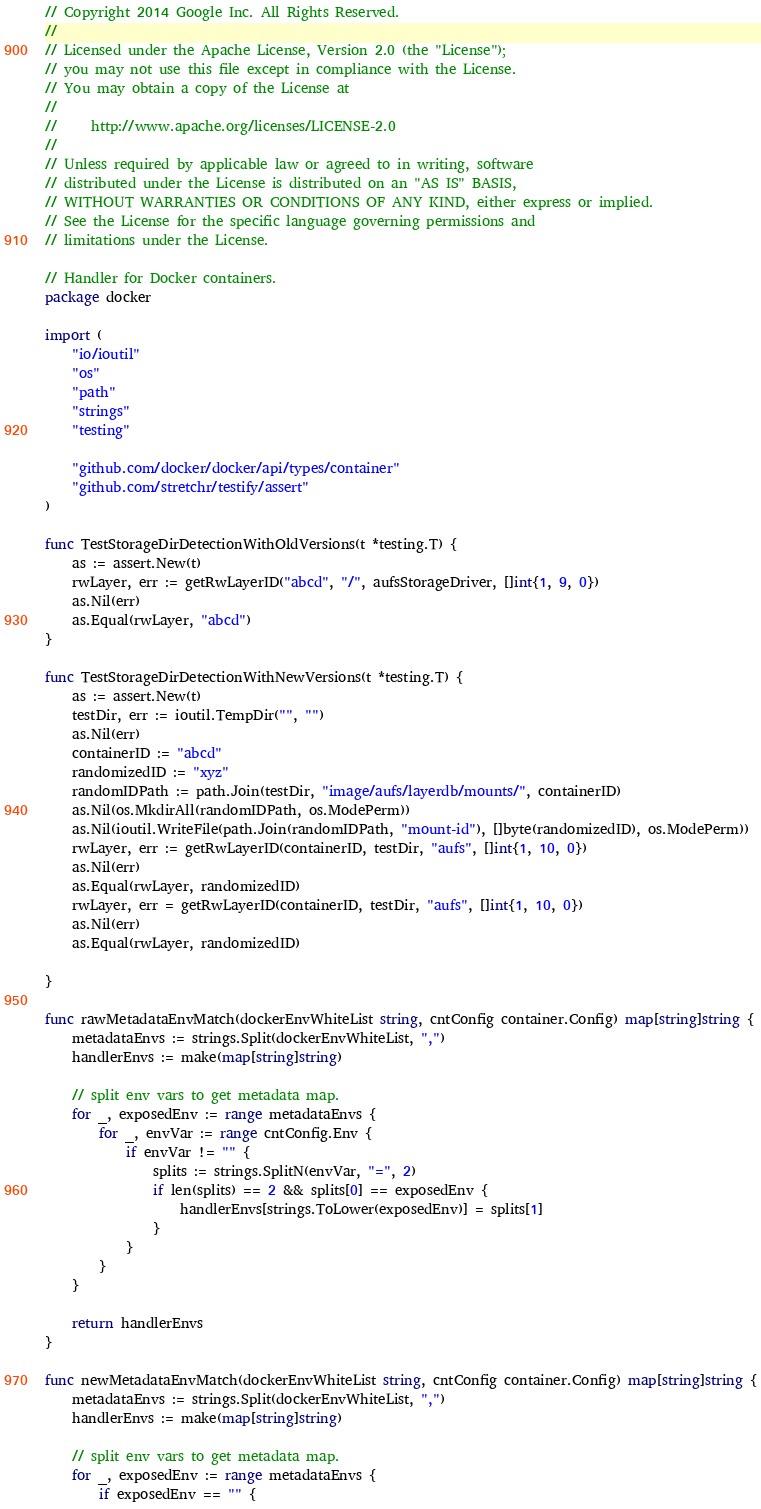<code> <loc_0><loc_0><loc_500><loc_500><_Go_>// Copyright 2014 Google Inc. All Rights Reserved.
//
// Licensed under the Apache License, Version 2.0 (the "License");
// you may not use this file except in compliance with the License.
// You may obtain a copy of the License at
//
//     http://www.apache.org/licenses/LICENSE-2.0
//
// Unless required by applicable law or agreed to in writing, software
// distributed under the License is distributed on an "AS IS" BASIS,
// WITHOUT WARRANTIES OR CONDITIONS OF ANY KIND, either express or implied.
// See the License for the specific language governing permissions and
// limitations under the License.

// Handler for Docker containers.
package docker

import (
	"io/ioutil"
	"os"
	"path"
	"strings"
	"testing"

	"github.com/docker/docker/api/types/container"
	"github.com/stretchr/testify/assert"
)

func TestStorageDirDetectionWithOldVersions(t *testing.T) {
	as := assert.New(t)
	rwLayer, err := getRwLayerID("abcd", "/", aufsStorageDriver, []int{1, 9, 0})
	as.Nil(err)
	as.Equal(rwLayer, "abcd")
}

func TestStorageDirDetectionWithNewVersions(t *testing.T) {
	as := assert.New(t)
	testDir, err := ioutil.TempDir("", "")
	as.Nil(err)
	containerID := "abcd"
	randomizedID := "xyz"
	randomIDPath := path.Join(testDir, "image/aufs/layerdb/mounts/", containerID)
	as.Nil(os.MkdirAll(randomIDPath, os.ModePerm))
	as.Nil(ioutil.WriteFile(path.Join(randomIDPath, "mount-id"), []byte(randomizedID), os.ModePerm))
	rwLayer, err := getRwLayerID(containerID, testDir, "aufs", []int{1, 10, 0})
	as.Nil(err)
	as.Equal(rwLayer, randomizedID)
	rwLayer, err = getRwLayerID(containerID, testDir, "aufs", []int{1, 10, 0})
	as.Nil(err)
	as.Equal(rwLayer, randomizedID)

}

func rawMetadataEnvMatch(dockerEnvWhiteList string, cntConfig container.Config) map[string]string {
	metadataEnvs := strings.Split(dockerEnvWhiteList, ",")
	handlerEnvs := make(map[string]string)

	// split env vars to get metadata map.
	for _, exposedEnv := range metadataEnvs {
		for _, envVar := range cntConfig.Env {
			if envVar != "" {
				splits := strings.SplitN(envVar, "=", 2)
				if len(splits) == 2 && splits[0] == exposedEnv {
					handlerEnvs[strings.ToLower(exposedEnv)] = splits[1]
				}
			}
		}
	}

	return handlerEnvs
}

func newMetadataEnvMatch(dockerEnvWhiteList string, cntConfig container.Config) map[string]string {
	metadataEnvs := strings.Split(dockerEnvWhiteList, ",")
	handlerEnvs := make(map[string]string)

	// split env vars to get metadata map.
	for _, exposedEnv := range metadataEnvs {
		if exposedEnv == "" {</code> 